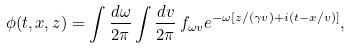Convert formula to latex. <formula><loc_0><loc_0><loc_500><loc_500>\phi ( t , x , z ) = \int \frac { d \omega } { 2 \pi } \int \frac { d v } { 2 \pi } \, f _ { \omega v } e ^ { - \omega [ z / ( \gamma v ) + i ( t - x / v ) ] } ,</formula> 